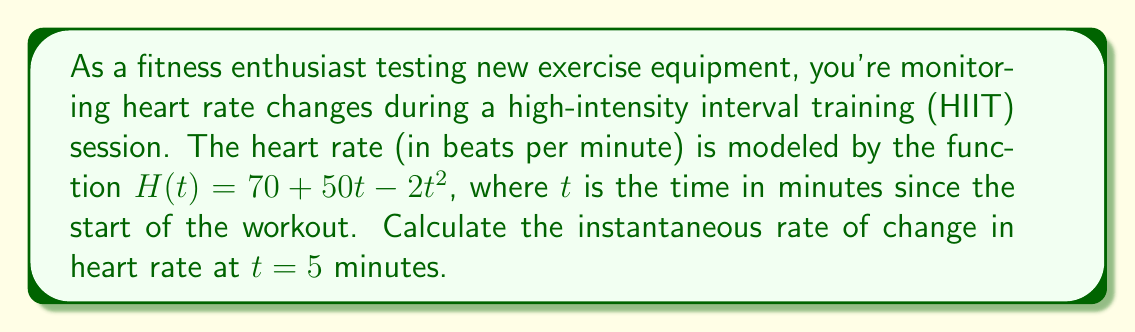Can you solve this math problem? To find the instantaneous rate of change in heart rate at $t = 5$ minutes, we need to calculate the derivative of the heart rate function $H(t)$ and evaluate it at $t = 5$.

Step 1: Find the derivative of $H(t)$.
$H(t) = 70 + 50t - 2t^2$
$H'(t) = 50 - 4t$ (using the power rule and constant rule of differentiation)

Step 2: Evaluate $H'(t)$ at $t = 5$.
$H'(5) = 50 - 4(5)$
$H'(5) = 50 - 20$
$H'(5) = 30$

The instantaneous rate of change at $t = 5$ minutes is 30 beats per minute per minute. This means that at the 5-minute mark, the heart rate is increasing at a rate of 30 bpm each minute.
Answer: 30 beats per minute per minute 